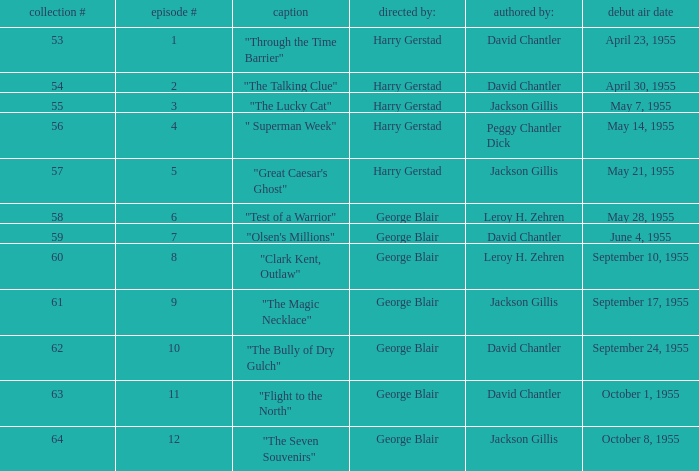Who directed the episode that was written by Jackson Gillis and Originally aired on May 21, 1955? Harry Gerstad. Write the full table. {'header': ['collection #', 'episode #', 'caption', 'directed by:', 'authored by:', 'debut air date'], 'rows': [['53', '1', '"Through the Time Barrier"', 'Harry Gerstad', 'David Chantler', 'April 23, 1955'], ['54', '2', '"The Talking Clue"', 'Harry Gerstad', 'David Chantler', 'April 30, 1955'], ['55', '3', '"The Lucky Cat"', 'Harry Gerstad', 'Jackson Gillis', 'May 7, 1955'], ['56', '4', '" Superman Week"', 'Harry Gerstad', 'Peggy Chantler Dick', 'May 14, 1955'], ['57', '5', '"Great Caesar\'s Ghost"', 'Harry Gerstad', 'Jackson Gillis', 'May 21, 1955'], ['58', '6', '"Test of a Warrior"', 'George Blair', 'Leroy H. Zehren', 'May 28, 1955'], ['59', '7', '"Olsen\'s Millions"', 'George Blair', 'David Chantler', 'June 4, 1955'], ['60', '8', '"Clark Kent, Outlaw"', 'George Blair', 'Leroy H. Zehren', 'September 10, 1955'], ['61', '9', '"The Magic Necklace"', 'George Blair', 'Jackson Gillis', 'September 17, 1955'], ['62', '10', '"The Bully of Dry Gulch"', 'George Blair', 'David Chantler', 'September 24, 1955'], ['63', '11', '"Flight to the North"', 'George Blair', 'David Chantler', 'October 1, 1955'], ['64', '12', '"The Seven Souvenirs"', 'George Blair', 'Jackson Gillis', 'October 8, 1955']]} 